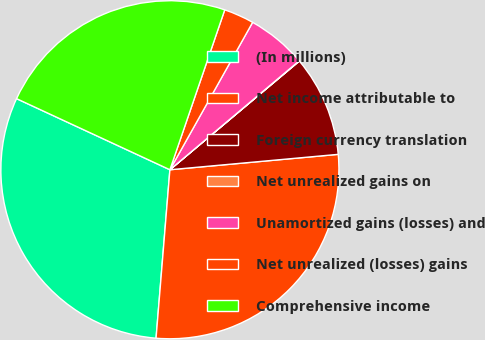<chart> <loc_0><loc_0><loc_500><loc_500><pie_chart><fcel>(In millions)<fcel>Net income attributable to<fcel>Foreign currency translation<fcel>Net unrealized gains on<fcel>Unamortized gains (losses) and<fcel>Net unrealized (losses) gains<fcel>Comprehensive income<nl><fcel>30.61%<fcel>27.76%<fcel>9.66%<fcel>0.03%<fcel>5.72%<fcel>2.88%<fcel>23.35%<nl></chart> 